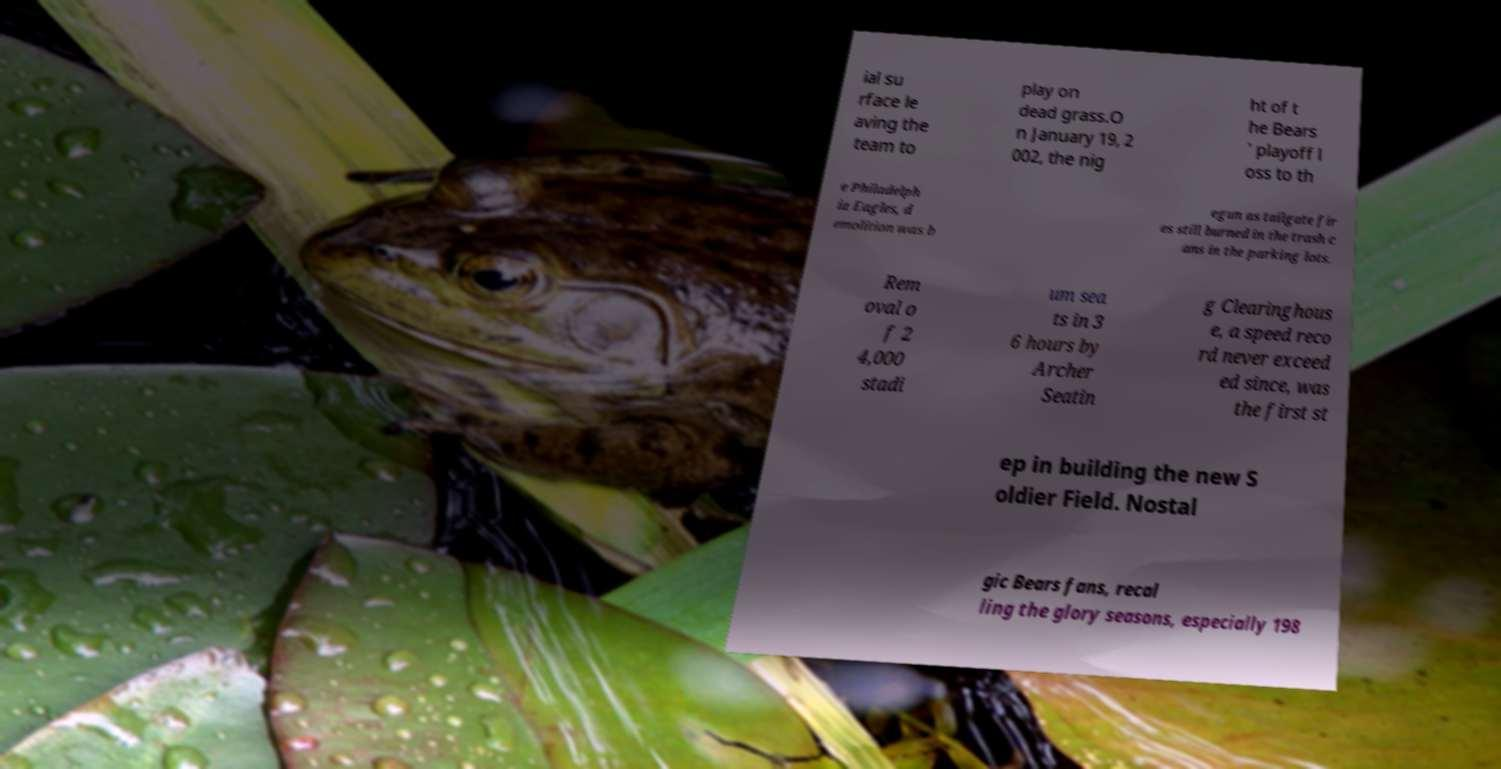I need the written content from this picture converted into text. Can you do that? ial su rface le aving the team to play on dead grass.O n January 19, 2 002, the nig ht of t he Bears ' playoff l oss to th e Philadelph ia Eagles, d emolition was b egun as tailgate fir es still burned in the trash c ans in the parking lots. Rem oval o f 2 4,000 stadi um sea ts in 3 6 hours by Archer Seatin g Clearinghous e, a speed reco rd never exceed ed since, was the first st ep in building the new S oldier Field. Nostal gic Bears fans, recal ling the glory seasons, especially 198 